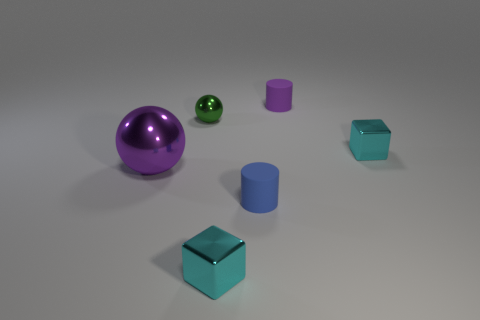What is the texture of the objects in the image? The objects appear to have smooth surfaces with varying degrees of reflectiveness. The spheres have a glossy finish, while the cylinders and cubes are less reflective. 